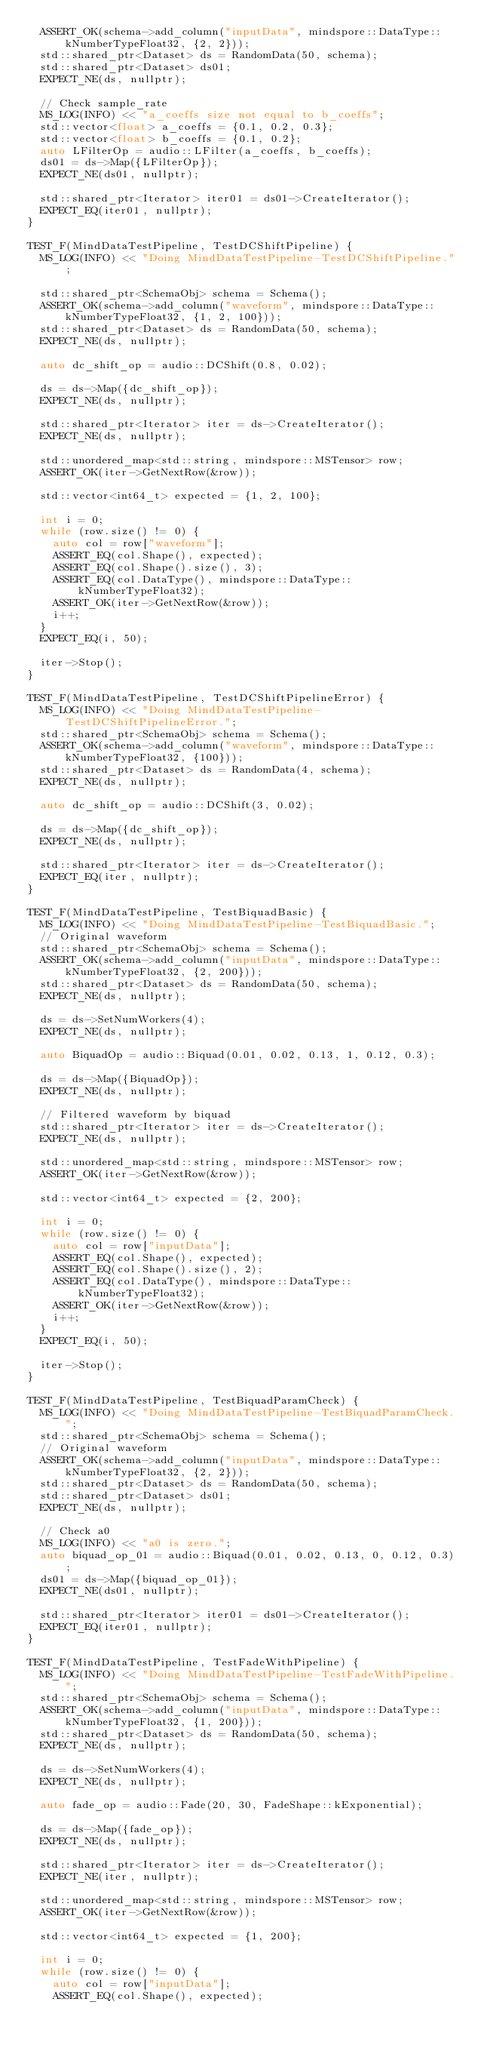Convert code to text. <code><loc_0><loc_0><loc_500><loc_500><_C++_>  ASSERT_OK(schema->add_column("inputData", mindspore::DataType::kNumberTypeFloat32, {2, 2}));
  std::shared_ptr<Dataset> ds = RandomData(50, schema);
  std::shared_ptr<Dataset> ds01;
  EXPECT_NE(ds, nullptr);

  // Check sample_rate
  MS_LOG(INFO) << "a_coeffs size not equal to b_coeffs";
  std::vector<float> a_coeffs = {0.1, 0.2, 0.3};
  std::vector<float> b_coeffs = {0.1, 0.2};
  auto LFilterOp = audio::LFilter(a_coeffs, b_coeffs);
  ds01 = ds->Map({LFilterOp});
  EXPECT_NE(ds01, nullptr);

  std::shared_ptr<Iterator> iter01 = ds01->CreateIterator();
  EXPECT_EQ(iter01, nullptr);
}

TEST_F(MindDataTestPipeline, TestDCShiftPipeline) {
  MS_LOG(INFO) << "Doing MindDataTestPipeline-TestDCShiftPipeline.";

  std::shared_ptr<SchemaObj> schema = Schema();
  ASSERT_OK(schema->add_column("waveform", mindspore::DataType::kNumberTypeFloat32, {1, 2, 100}));
  std::shared_ptr<Dataset> ds = RandomData(50, schema);
  EXPECT_NE(ds, nullptr);

  auto dc_shift_op = audio::DCShift(0.8, 0.02);

  ds = ds->Map({dc_shift_op});
  EXPECT_NE(ds, nullptr);

  std::shared_ptr<Iterator> iter = ds->CreateIterator();
  EXPECT_NE(ds, nullptr);

  std::unordered_map<std::string, mindspore::MSTensor> row;
  ASSERT_OK(iter->GetNextRow(&row));

  std::vector<int64_t> expected = {1, 2, 100};

  int i = 0;
  while (row.size() != 0) {
    auto col = row["waveform"];
    ASSERT_EQ(col.Shape(), expected);
    ASSERT_EQ(col.Shape().size(), 3);
    ASSERT_EQ(col.DataType(), mindspore::DataType::kNumberTypeFloat32);
    ASSERT_OK(iter->GetNextRow(&row));
    i++;
  }
  EXPECT_EQ(i, 50);

  iter->Stop();
}

TEST_F(MindDataTestPipeline, TestDCShiftPipelineError) {
  MS_LOG(INFO) << "Doing MindDataTestPipeline-TestDCShiftPipelineError.";
  std::shared_ptr<SchemaObj> schema = Schema();
  ASSERT_OK(schema->add_column("waveform", mindspore::DataType::kNumberTypeFloat32, {100}));
  std::shared_ptr<Dataset> ds = RandomData(4, schema);
  EXPECT_NE(ds, nullptr);

  auto dc_shift_op = audio::DCShift(3, 0.02);

  ds = ds->Map({dc_shift_op});
  EXPECT_NE(ds, nullptr);

  std::shared_ptr<Iterator> iter = ds->CreateIterator();
  EXPECT_EQ(iter, nullptr);
}

TEST_F(MindDataTestPipeline, TestBiquadBasic) {
  MS_LOG(INFO) << "Doing MindDataTestPipeline-TestBiquadBasic.";
  // Original waveform
  std::shared_ptr<SchemaObj> schema = Schema();
  ASSERT_OK(schema->add_column("inputData", mindspore::DataType::kNumberTypeFloat32, {2, 200}));
  std::shared_ptr<Dataset> ds = RandomData(50, schema);
  EXPECT_NE(ds, nullptr);

  ds = ds->SetNumWorkers(4);
  EXPECT_NE(ds, nullptr);

  auto BiquadOp = audio::Biquad(0.01, 0.02, 0.13, 1, 0.12, 0.3);

  ds = ds->Map({BiquadOp});
  EXPECT_NE(ds, nullptr);

  // Filtered waveform by biquad
  std::shared_ptr<Iterator> iter = ds->CreateIterator();
  EXPECT_NE(ds, nullptr);

  std::unordered_map<std::string, mindspore::MSTensor> row;
  ASSERT_OK(iter->GetNextRow(&row));

  std::vector<int64_t> expected = {2, 200};

  int i = 0;
  while (row.size() != 0) {
    auto col = row["inputData"];
    ASSERT_EQ(col.Shape(), expected);
    ASSERT_EQ(col.Shape().size(), 2);
    ASSERT_EQ(col.DataType(), mindspore::DataType::kNumberTypeFloat32);
    ASSERT_OK(iter->GetNextRow(&row));
    i++;
  }
  EXPECT_EQ(i, 50);

  iter->Stop();
}

TEST_F(MindDataTestPipeline, TestBiquadParamCheck) {
  MS_LOG(INFO) << "Doing MindDataTestPipeline-TestBiquadParamCheck.";
  std::shared_ptr<SchemaObj> schema = Schema();
  // Original waveform
  ASSERT_OK(schema->add_column("inputData", mindspore::DataType::kNumberTypeFloat32, {2, 2}));
  std::shared_ptr<Dataset> ds = RandomData(50, schema);
  std::shared_ptr<Dataset> ds01;
  EXPECT_NE(ds, nullptr);

  // Check a0
  MS_LOG(INFO) << "a0 is zero.";
  auto biquad_op_01 = audio::Biquad(0.01, 0.02, 0.13, 0, 0.12, 0.3);
  ds01 = ds->Map({biquad_op_01});
  EXPECT_NE(ds01, nullptr);

  std::shared_ptr<Iterator> iter01 = ds01->CreateIterator();
  EXPECT_EQ(iter01, nullptr);
}

TEST_F(MindDataTestPipeline, TestFadeWithPipeline) {
  MS_LOG(INFO) << "Doing MindDataTestPipeline-TestFadeWithPipeline.";
  std::shared_ptr<SchemaObj> schema = Schema();
  ASSERT_OK(schema->add_column("inputData", mindspore::DataType::kNumberTypeFloat32, {1, 200}));
  std::shared_ptr<Dataset> ds = RandomData(50, schema);
  EXPECT_NE(ds, nullptr);

  ds = ds->SetNumWorkers(4);
  EXPECT_NE(ds, nullptr);

  auto fade_op = audio::Fade(20, 30, FadeShape::kExponential);

  ds = ds->Map({fade_op});
  EXPECT_NE(ds, nullptr);

  std::shared_ptr<Iterator> iter = ds->CreateIterator();
  EXPECT_NE(iter, nullptr);

  std::unordered_map<std::string, mindspore::MSTensor> row;
  ASSERT_OK(iter->GetNextRow(&row));

  std::vector<int64_t> expected = {1, 200};

  int i = 0;
  while (row.size() != 0) {
    auto col = row["inputData"];
    ASSERT_EQ(col.Shape(), expected);</code> 